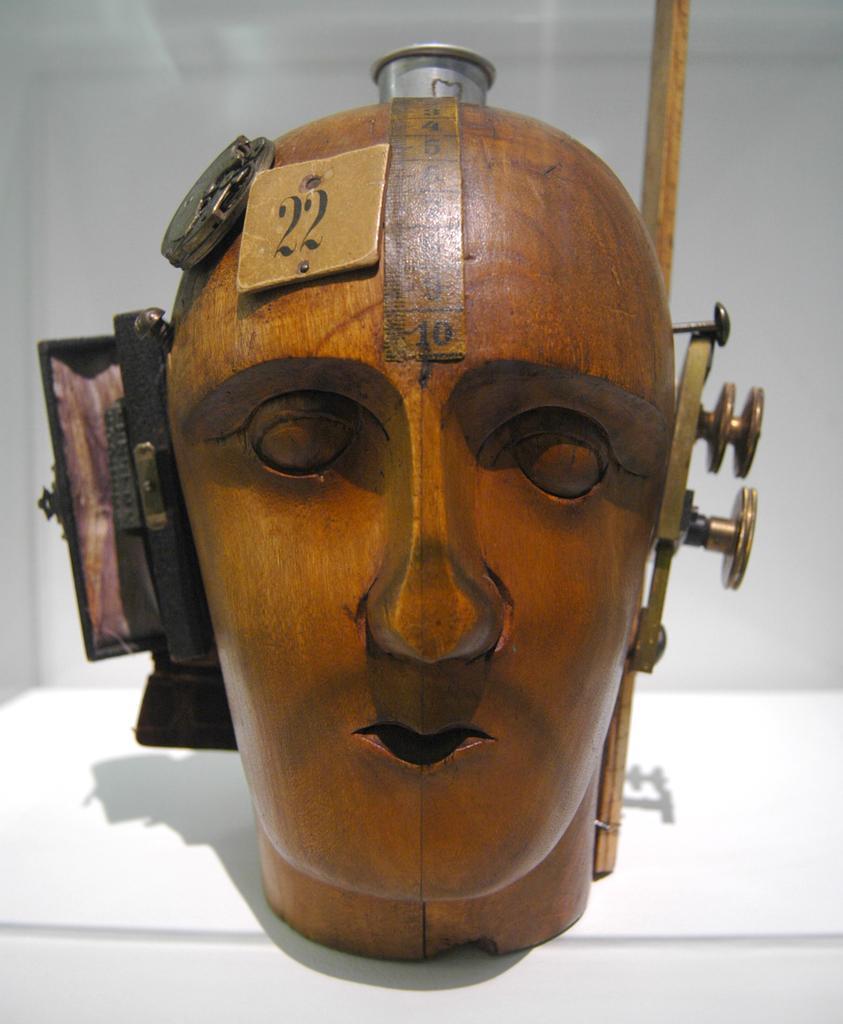In one or two sentences, can you explain what this image depicts? I think this is a wooden machine, which is carved like a human face. These are the objects, which are fixed to this wooden machine. The background looks white in color. 